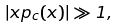Convert formula to latex. <formula><loc_0><loc_0><loc_500><loc_500>| x p _ { c } ( x ) | \gg 1 ,</formula> 